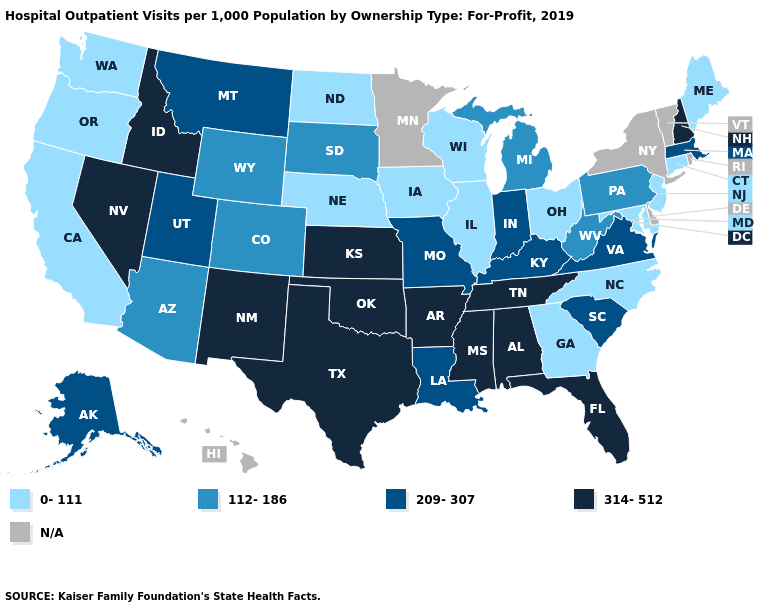Does Kansas have the highest value in the USA?
Short answer required. Yes. Among the states that border Wyoming , which have the lowest value?
Short answer required. Nebraska. What is the value of Texas?
Quick response, please. 314-512. Does Connecticut have the lowest value in the USA?
Write a very short answer. Yes. Does New Hampshire have the highest value in the USA?
Short answer required. Yes. What is the lowest value in states that border South Carolina?
Answer briefly. 0-111. Is the legend a continuous bar?
Quick response, please. No. Does Tennessee have the lowest value in the USA?
Give a very brief answer. No. Name the states that have a value in the range 314-512?
Be succinct. Alabama, Arkansas, Florida, Idaho, Kansas, Mississippi, Nevada, New Hampshire, New Mexico, Oklahoma, Tennessee, Texas. Does the map have missing data?
Short answer required. Yes. What is the value of Colorado?
Quick response, please. 112-186. What is the value of Rhode Island?
Give a very brief answer. N/A. What is the value of Massachusetts?
Concise answer only. 209-307. What is the value of Florida?
Write a very short answer. 314-512. 